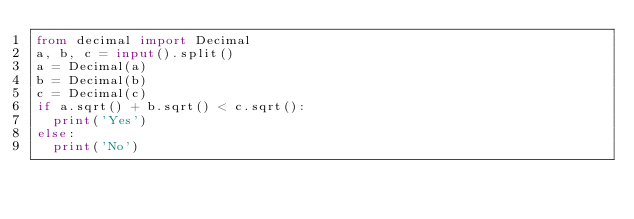<code> <loc_0><loc_0><loc_500><loc_500><_Python_>from decimal import Decimal
a, b, c = input().split()
a = Decimal(a)
b = Decimal(b)
c = Decimal(c)
if a.sqrt() + b.sqrt() < c.sqrt():
  print('Yes')
else:
  print('No')</code> 